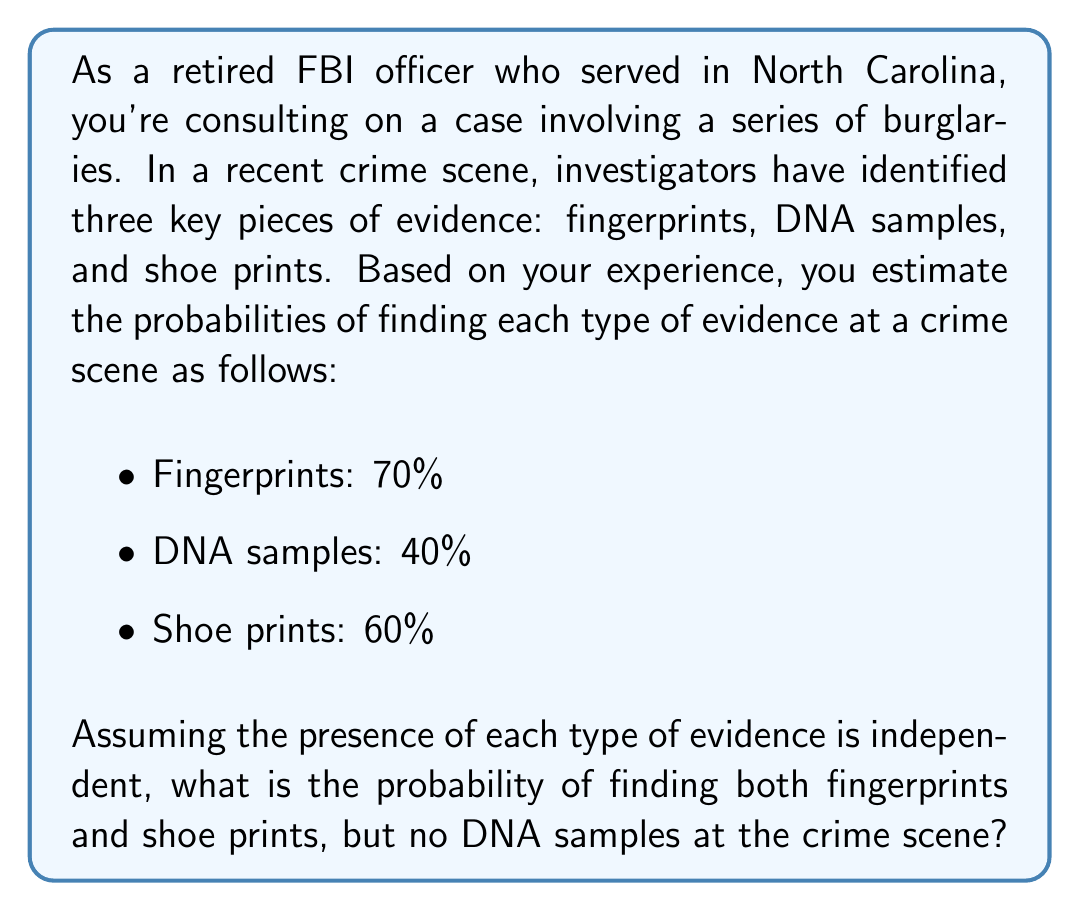What is the answer to this math problem? To solve this problem, we need to use the concept of probability for independent events. Let's break it down step by step:

1) Let's define our events:
   F: Fingerprints are found (P(F) = 0.70)
   D: DNA samples are found (P(D) = 0.40)
   S: Shoe prints are found (P(S) = 0.60)

2) We want to find the probability of F and S occurring, but not D. In probability notation, this is:

   P(F ∩ S ∩ D')

   Where D' represents the complement of D (i.e., DNA samples are not found).

3) Since the events are independent, we can multiply their individual probabilities:

   P(F ∩ S ∩ D') = P(F) × P(S) × P(D')

4) We know P(F) and P(S), but we need to calculate P(D'):

   P(D') = 1 - P(D) = 1 - 0.40 = 0.60

5) Now we can plug in all our values:

   P(F ∩ S ∩ D') = 0.70 × 0.60 × 0.60

6) Let's calculate:

   $$P(F ∩ S ∩ D') = 0.70 \times 0.60 \times 0.60 = 0.252$$

Therefore, the probability of finding both fingerprints and shoe prints, but no DNA samples, is 0.252 or 25.2%.
Answer: 0.252 or 25.2% 